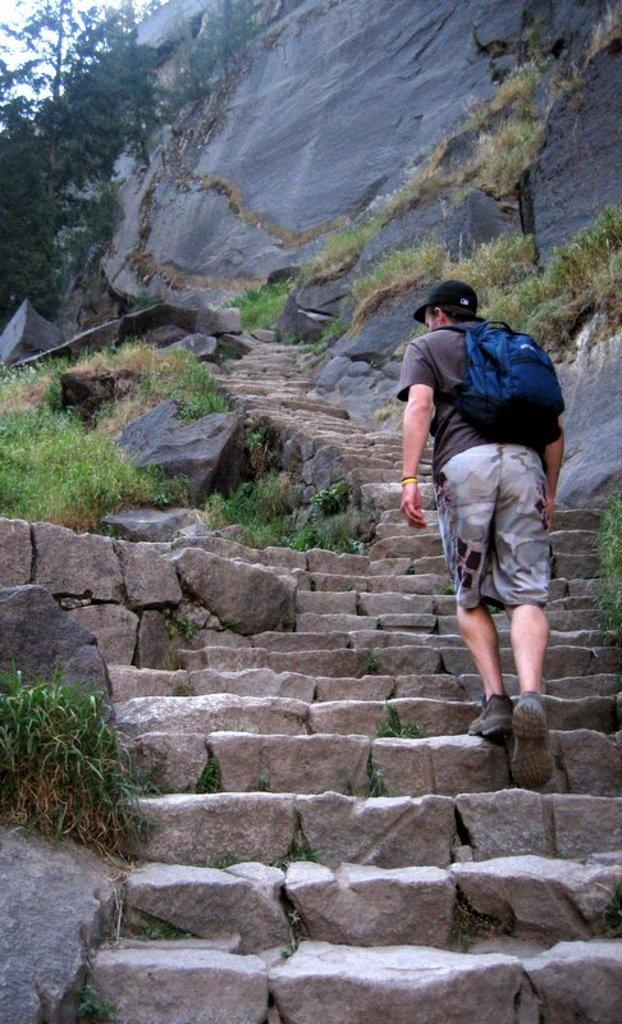What is the main action being performed by the person in the image? The person is walking on stairs in the image. Where is the person located in the image? The person is in the center of the image. What can be seen in the top part of the image? There are mountains, trees, and plants in the top part of the image. What type of game is being played in the image? There is no game being played in the image; it features a person walking on stairs and a background with mountains, trees, and plants. Can you see an ocean in the image? There is no ocean visible in the image. 